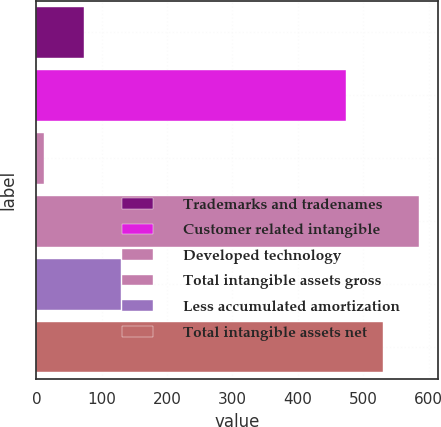Convert chart to OTSL. <chart><loc_0><loc_0><loc_500><loc_500><bar_chart><fcel>Trademarks and tradenames<fcel>Customer related intangible<fcel>Developed technology<fcel>Total intangible assets gross<fcel>Less accumulated amortization<fcel>Total intangible assets net<nl><fcel>73<fcel>474<fcel>12<fcel>585.6<fcel>128.8<fcel>529.8<nl></chart> 